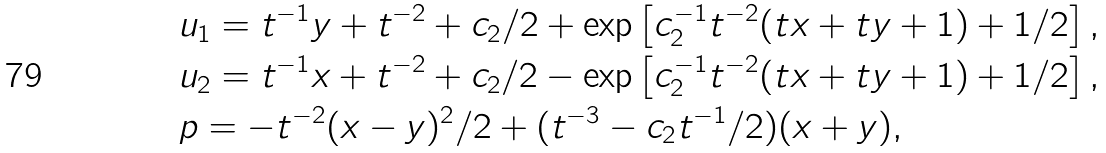<formula> <loc_0><loc_0><loc_500><loc_500>& u _ { 1 } = t ^ { - 1 } y + t ^ { - 2 } + c _ { 2 } / 2 + \exp \left [ c _ { 2 } ^ { - 1 } t ^ { - 2 } ( t x + t y + 1 ) + 1 / 2 \right ] , \\ & u _ { 2 } = t ^ { - 1 } x + t ^ { - 2 } + c _ { 2 } / 2 - \exp \left [ c _ { 2 } ^ { - 1 } t ^ { - 2 } ( t x + t y + 1 ) + 1 / 2 \right ] , \\ & p = - t ^ { - 2 } ( x - y ) ^ { 2 } / 2 + ( t ^ { - 3 } - c _ { 2 } t ^ { - 1 } / 2 ) ( x + y ) ,</formula> 